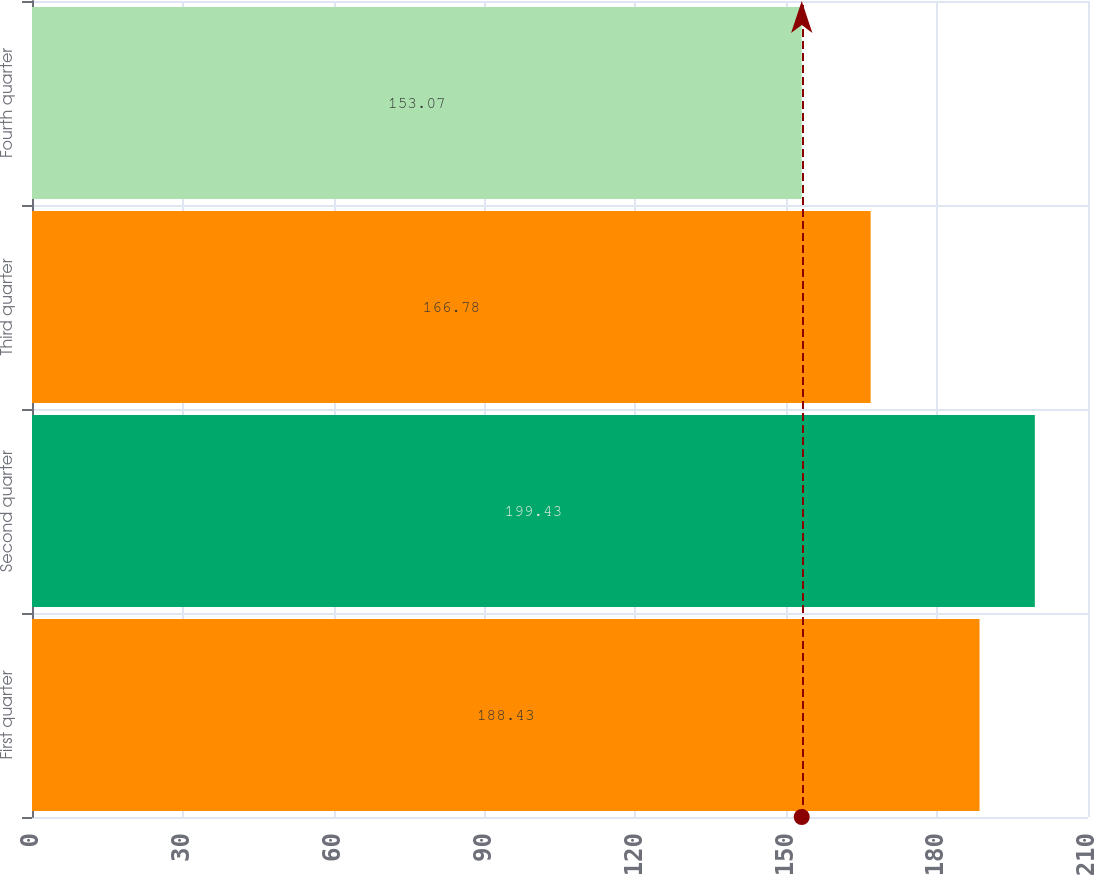Convert chart to OTSL. <chart><loc_0><loc_0><loc_500><loc_500><bar_chart><fcel>First quarter<fcel>Second quarter<fcel>Third quarter<fcel>Fourth quarter<nl><fcel>188.43<fcel>199.43<fcel>166.78<fcel>153.07<nl></chart> 